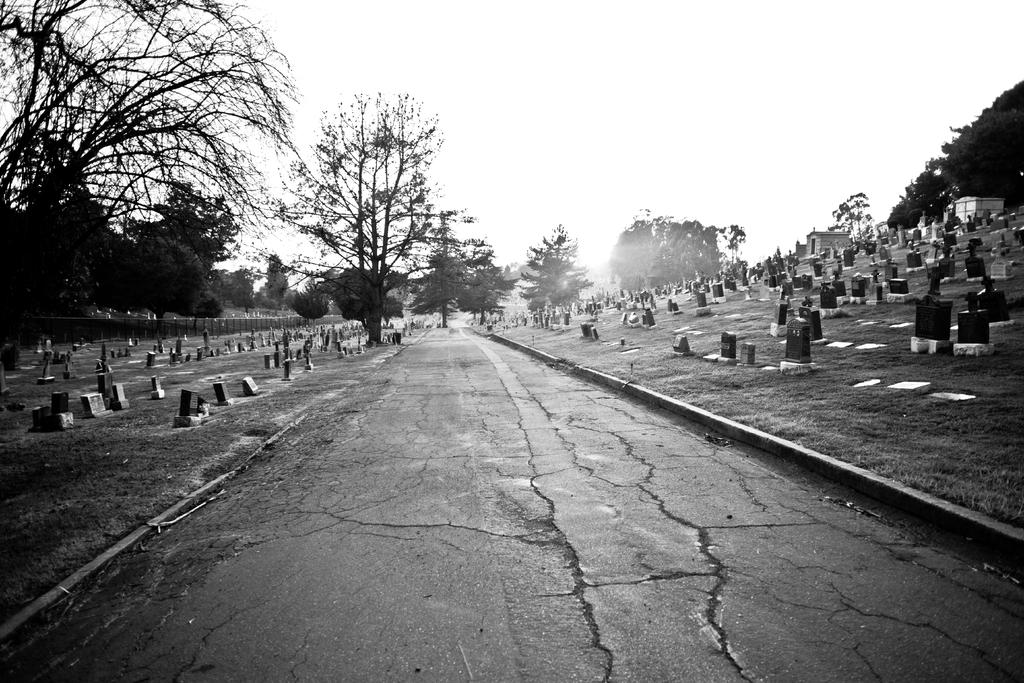What is the main feature in the middle of the image? There is a road in the middle of the image. What can be seen on both sides of the road? There are cemeteries on both sides of the road. What type of vegetation is visible in the background of the image? There are trees in the background of the image. How would you describe the sky in the image? The sky is clear in the image. What type of discovery was made at the spot where the road intersects with the cemetery? There is no mention of a discovery in the image or the provided facts, and the image does not show any spot where the road intersects with the cemetery. 